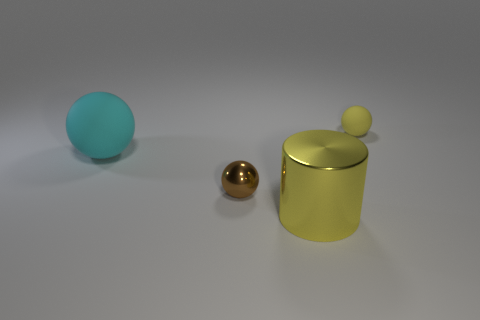Can you explain the different materials visible in the image? Certainly! In the image, we see objects with different materials. On the left, there is a large blue ball that appears to have a matte, rubbery texture. In the center, there's a smaller, shiny golden ball that seems to be made of metal. Lastly, on the right, there is a large yellow cylindrical container with a metallic sheen and a small ball on its lid, indicatively also made of metal. 